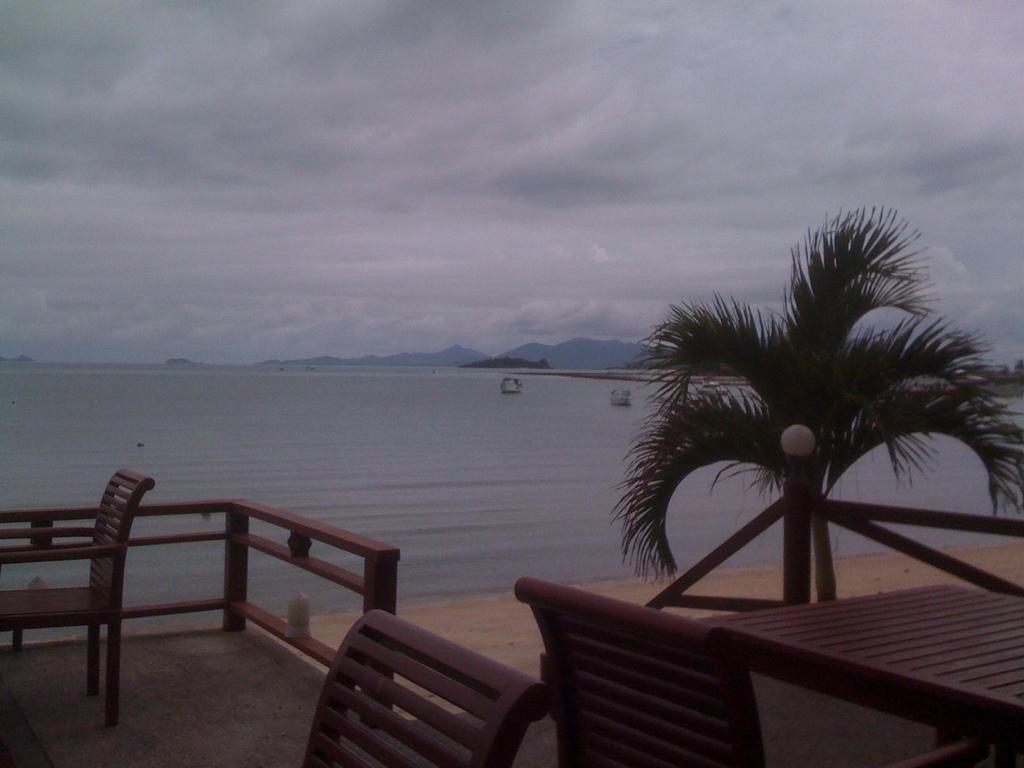Can you describe this image briefly? In this image, at the bottom there are chairs, railing, table, plant. In the background there are boats, water, waves, hills, sky. 